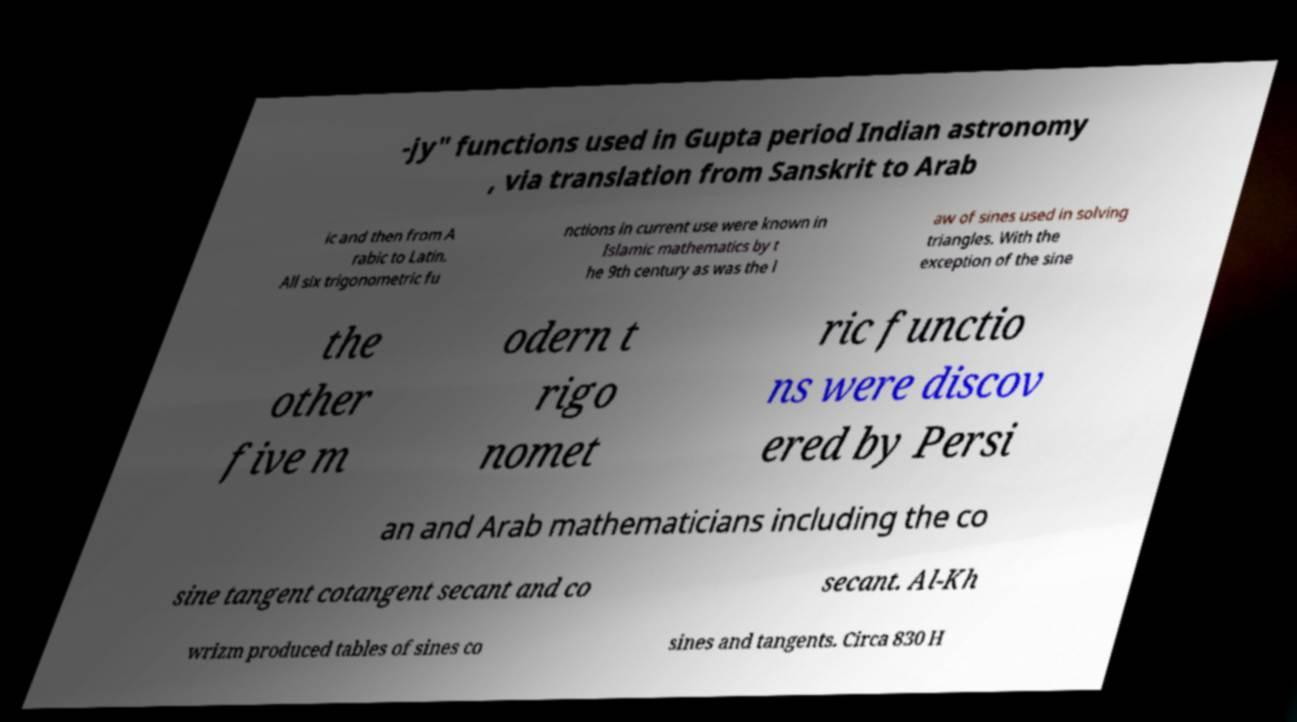I need the written content from this picture converted into text. Can you do that? -jy" functions used in Gupta period Indian astronomy , via translation from Sanskrit to Arab ic and then from A rabic to Latin. All six trigonometric fu nctions in current use were known in Islamic mathematics by t he 9th century as was the l aw of sines used in solving triangles. With the exception of the sine the other five m odern t rigo nomet ric functio ns were discov ered by Persi an and Arab mathematicians including the co sine tangent cotangent secant and co secant. Al-Kh wrizm produced tables of sines co sines and tangents. Circa 830 H 